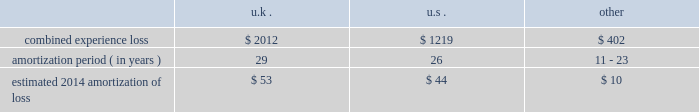Period .
The discount reflects our incremental borrowing rate , which matches the lifetime of the liability .
Significant changes in the discount rate selected or the estimations of sublease income in the case of leases could impact the amounts recorded .
Other associated costs with restructuring activities we recognize other costs associated with restructuring activities as they are incurred , including moving costs and consulting and legal fees .
Pensions we sponsor defined benefit pension plans throughout the world .
Our most significant plans are located in the u.s. , the u.k. , the netherlands and canada .
Our significant u.s. , u.k .
And canadian pension plans are closed to new entrants .
We have ceased crediting future benefits relating to salary and service for our u.s. , u.k .
And canadian plans .
Recognition of gains and losses and prior service certain changes in the value of the obligation and in the value of plan assets , which may occur due to various factors such as changes in the discount rate and actuarial assumptions , actual demographic experience and/or plan asset performance are not immediately recognized in net income .
Such changes are recognized in other comprehensive income and are amortized into net income as part of the net periodic benefit cost .
Unrecognized gains and losses that have been deferred in other comprehensive income , as previously described , are amortized into compensation and benefits expense as a component of periodic pension expense based on the average expected future service of active employees for our plans in the netherlands and canada , or the average life expectancy of the u.s .
And u.k .
Plan members .
After the effective date of the plan amendments to cease crediting future benefits relating to service , unrecognized gains and losses are also be based on the average life expectancy of members in the canadian plans .
We amortize any prior service expense or credits that arise as a result of plan changes over a period consistent with the amortization of gains and losses .
As of december 31 , 2013 , our pension plans have deferred losses that have not yet been recognized through income in the consolidated financial statements .
We amortize unrecognized actuarial losses outside of a corridor , which is defined as 10% ( 10 % ) of the greater of market-related value of plan assets or projected benefit obligation .
To the extent not offset by future gains , incremental amortization as calculated above will continue to affect future pension expense similarly until fully amortized .
The table discloses our combined experience loss , the number of years over which we are amortizing the experience loss , and the estimated 2014 amortization of loss by country ( amounts in millions ) : .
The unrecognized prior service cost at december 31 , 2013 was $ 27 million in the u.k .
And other plans .
For the u.s .
Pension plans we use a market-related valuation of assets approach to determine the expected return on assets , which is a component of net periodic benefit cost recognized in the consolidated statements of income .
This approach recognizes 20% ( 20 % ) of any gains or losses in the current year's value of market-related assets , with the remaining 80% ( 80 % ) spread over the next four years .
As this approach recognizes gains or losses over a five-year period , the future value of assets and therefore , our net periodic benefit cost will be impacted as previously deferred gains or losses are recorded .
As of december 31 , 2013 , the market-related value of assets was $ 1.8 billion .
We do not use the market-related valuation approach to determine the funded status of the u.s .
Plans recorded in the consolidated statements of financial position .
Instead , we record and present the funded status in the consolidated statements of financial position based on the fair value of the plan assets .
As of december 31 , 2013 , the fair value of plan assets was $ 1.9 billion .
Our non-u.s .
Plans use fair value to determine expected return on assets. .
What is the total combined experience loss aon , ( in millions ) ? 
Computations: ((2012 + 1219) + 402)
Answer: 3633.0. 